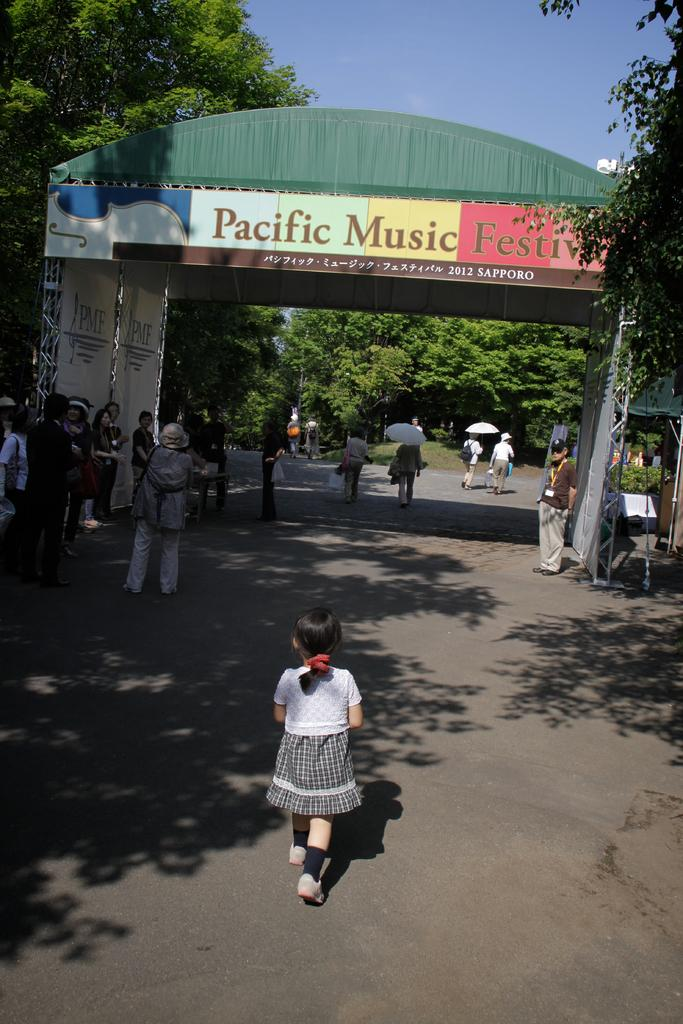What are the people in the image doing? The persons in the image are standing on the road. What can be seen in the sky in the image? The sky is visible in the image. What type of vegetation is present in the image? There are trees in the image. What type of structure is present in the image? Iron grills are present in the image. What type of signage is visible in the image? Advertisement boards are visible in the image. What type of architectural feature is present in the image? There is an arch in the image. What type of jeans can be seen in the image? There are no jeans present in the image. Is there a mine visible in the image? There is no mine present in the image. 